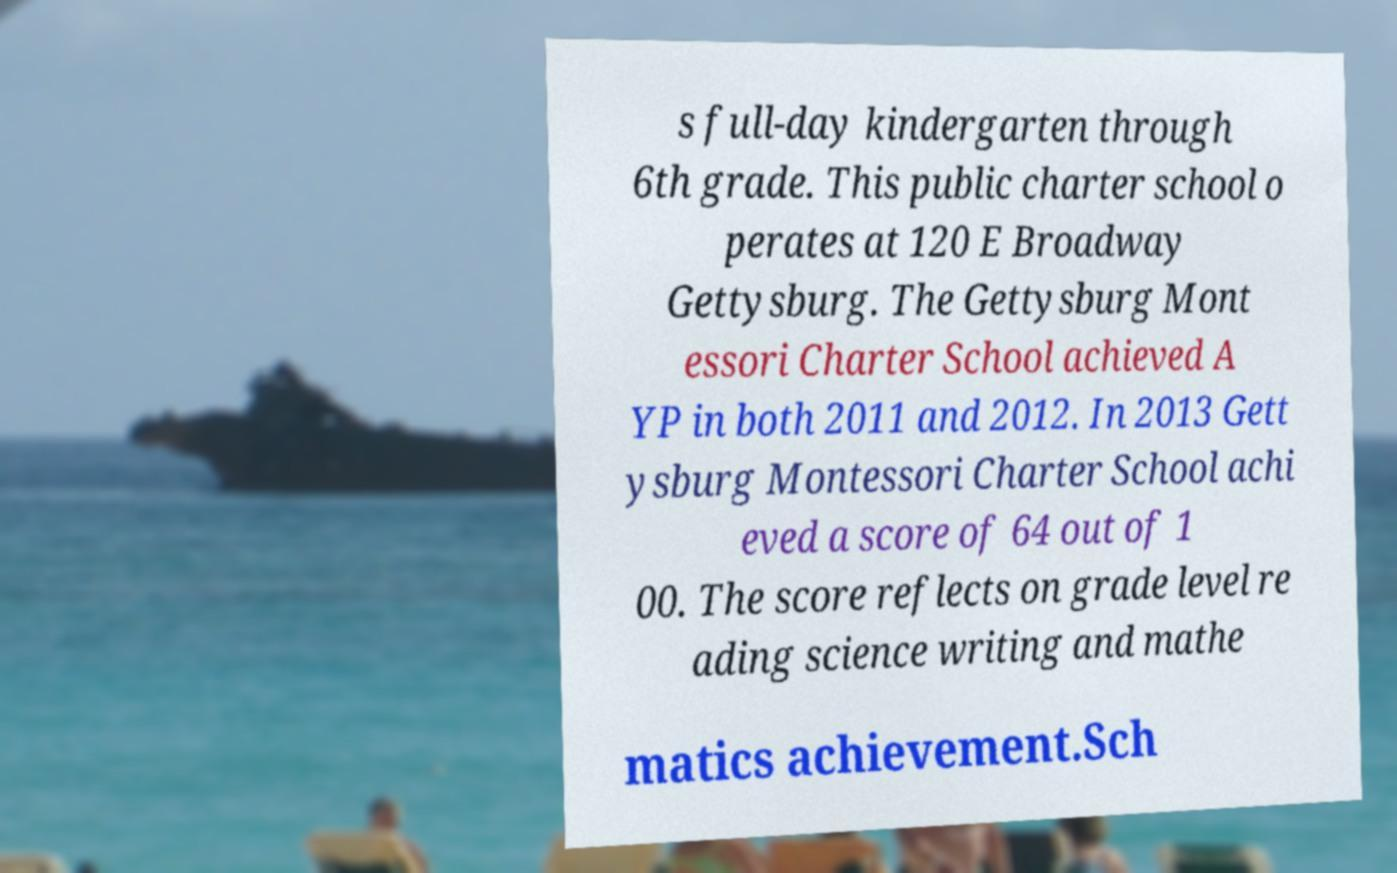There's text embedded in this image that I need extracted. Can you transcribe it verbatim? s full-day kindergarten through 6th grade. This public charter school o perates at 120 E Broadway Gettysburg. The Gettysburg Mont essori Charter School achieved A YP in both 2011 and 2012. In 2013 Gett ysburg Montessori Charter School achi eved a score of 64 out of 1 00. The score reflects on grade level re ading science writing and mathe matics achievement.Sch 